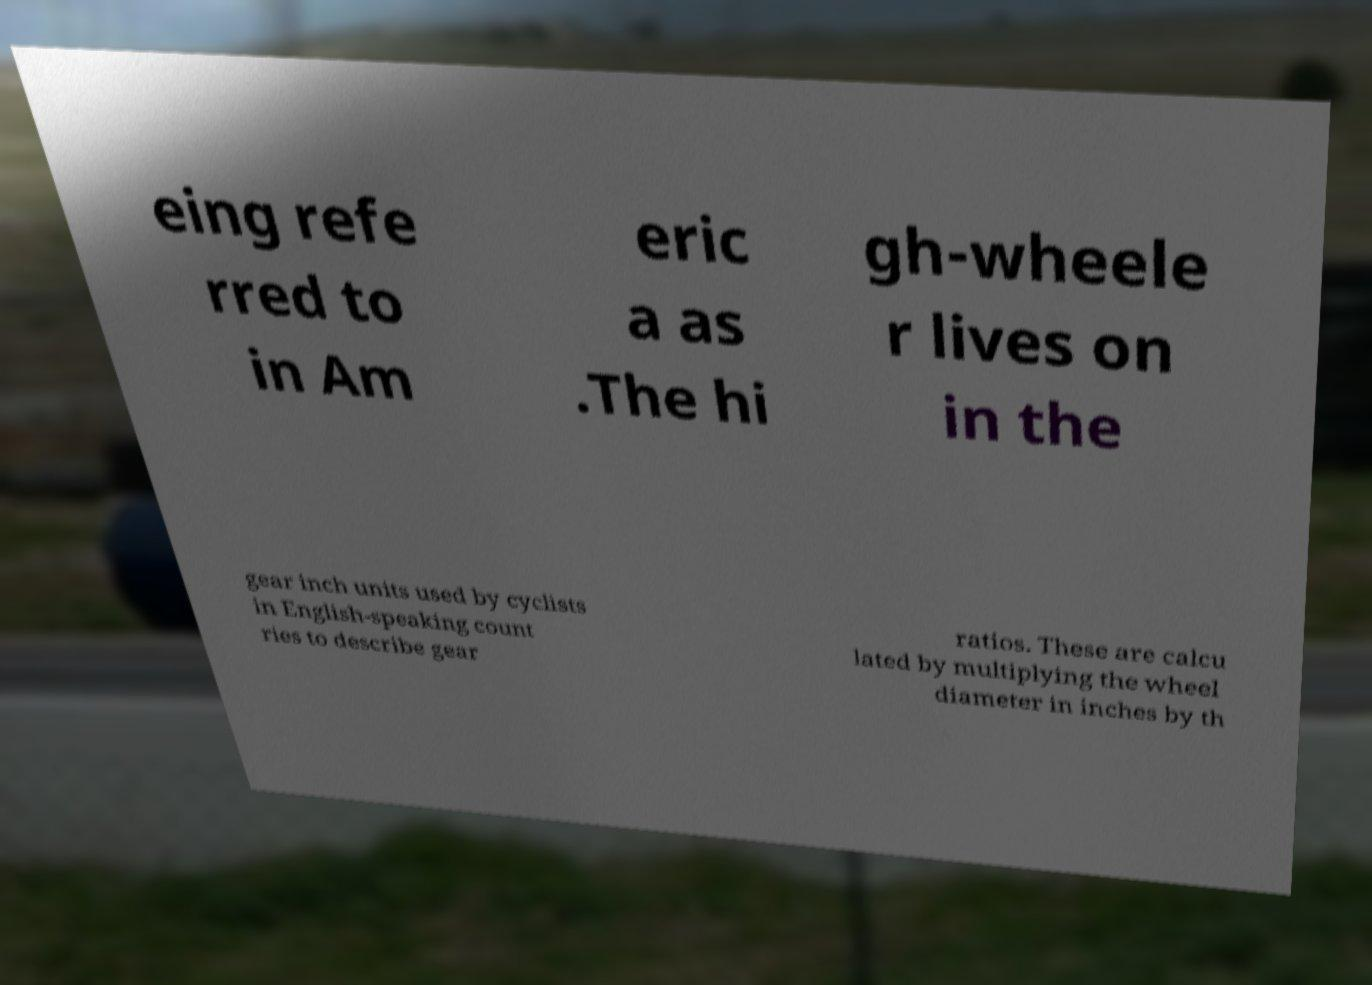For documentation purposes, I need the text within this image transcribed. Could you provide that? eing refe rred to in Am eric a as .The hi gh-wheele r lives on in the gear inch units used by cyclists in English-speaking count ries to describe gear ratios. These are calcu lated by multiplying the wheel diameter in inches by th 